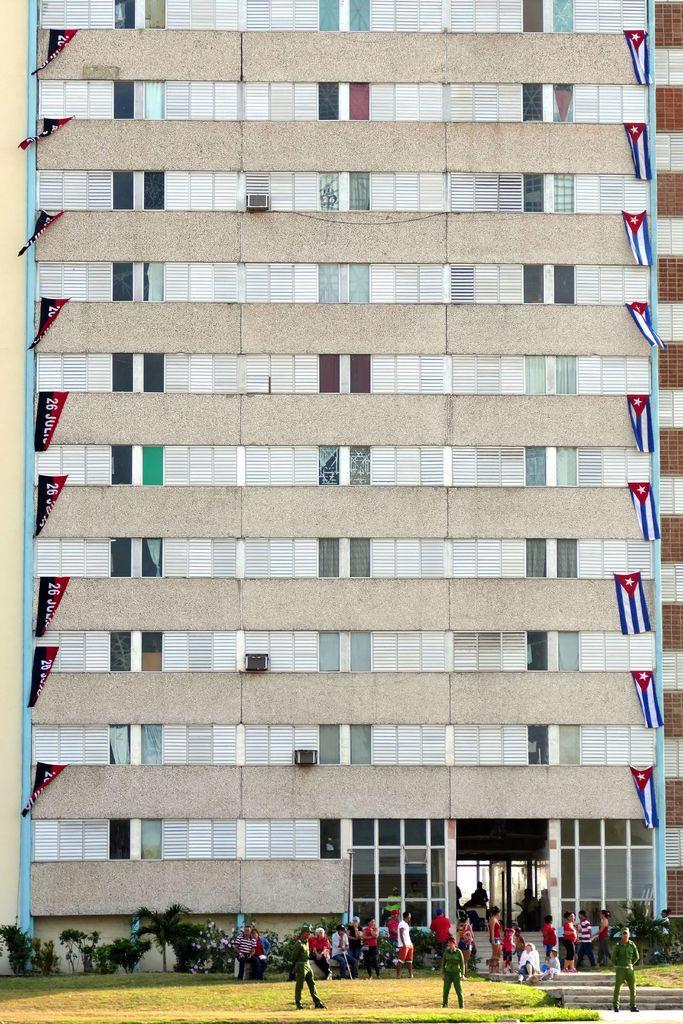How would you summarize this image in a sentence or two? In this image we can see a group of people standing on the floor, two people are sitting, staircase. In the background, we can see a group of trees, building with windows,air conditioners and flags. 